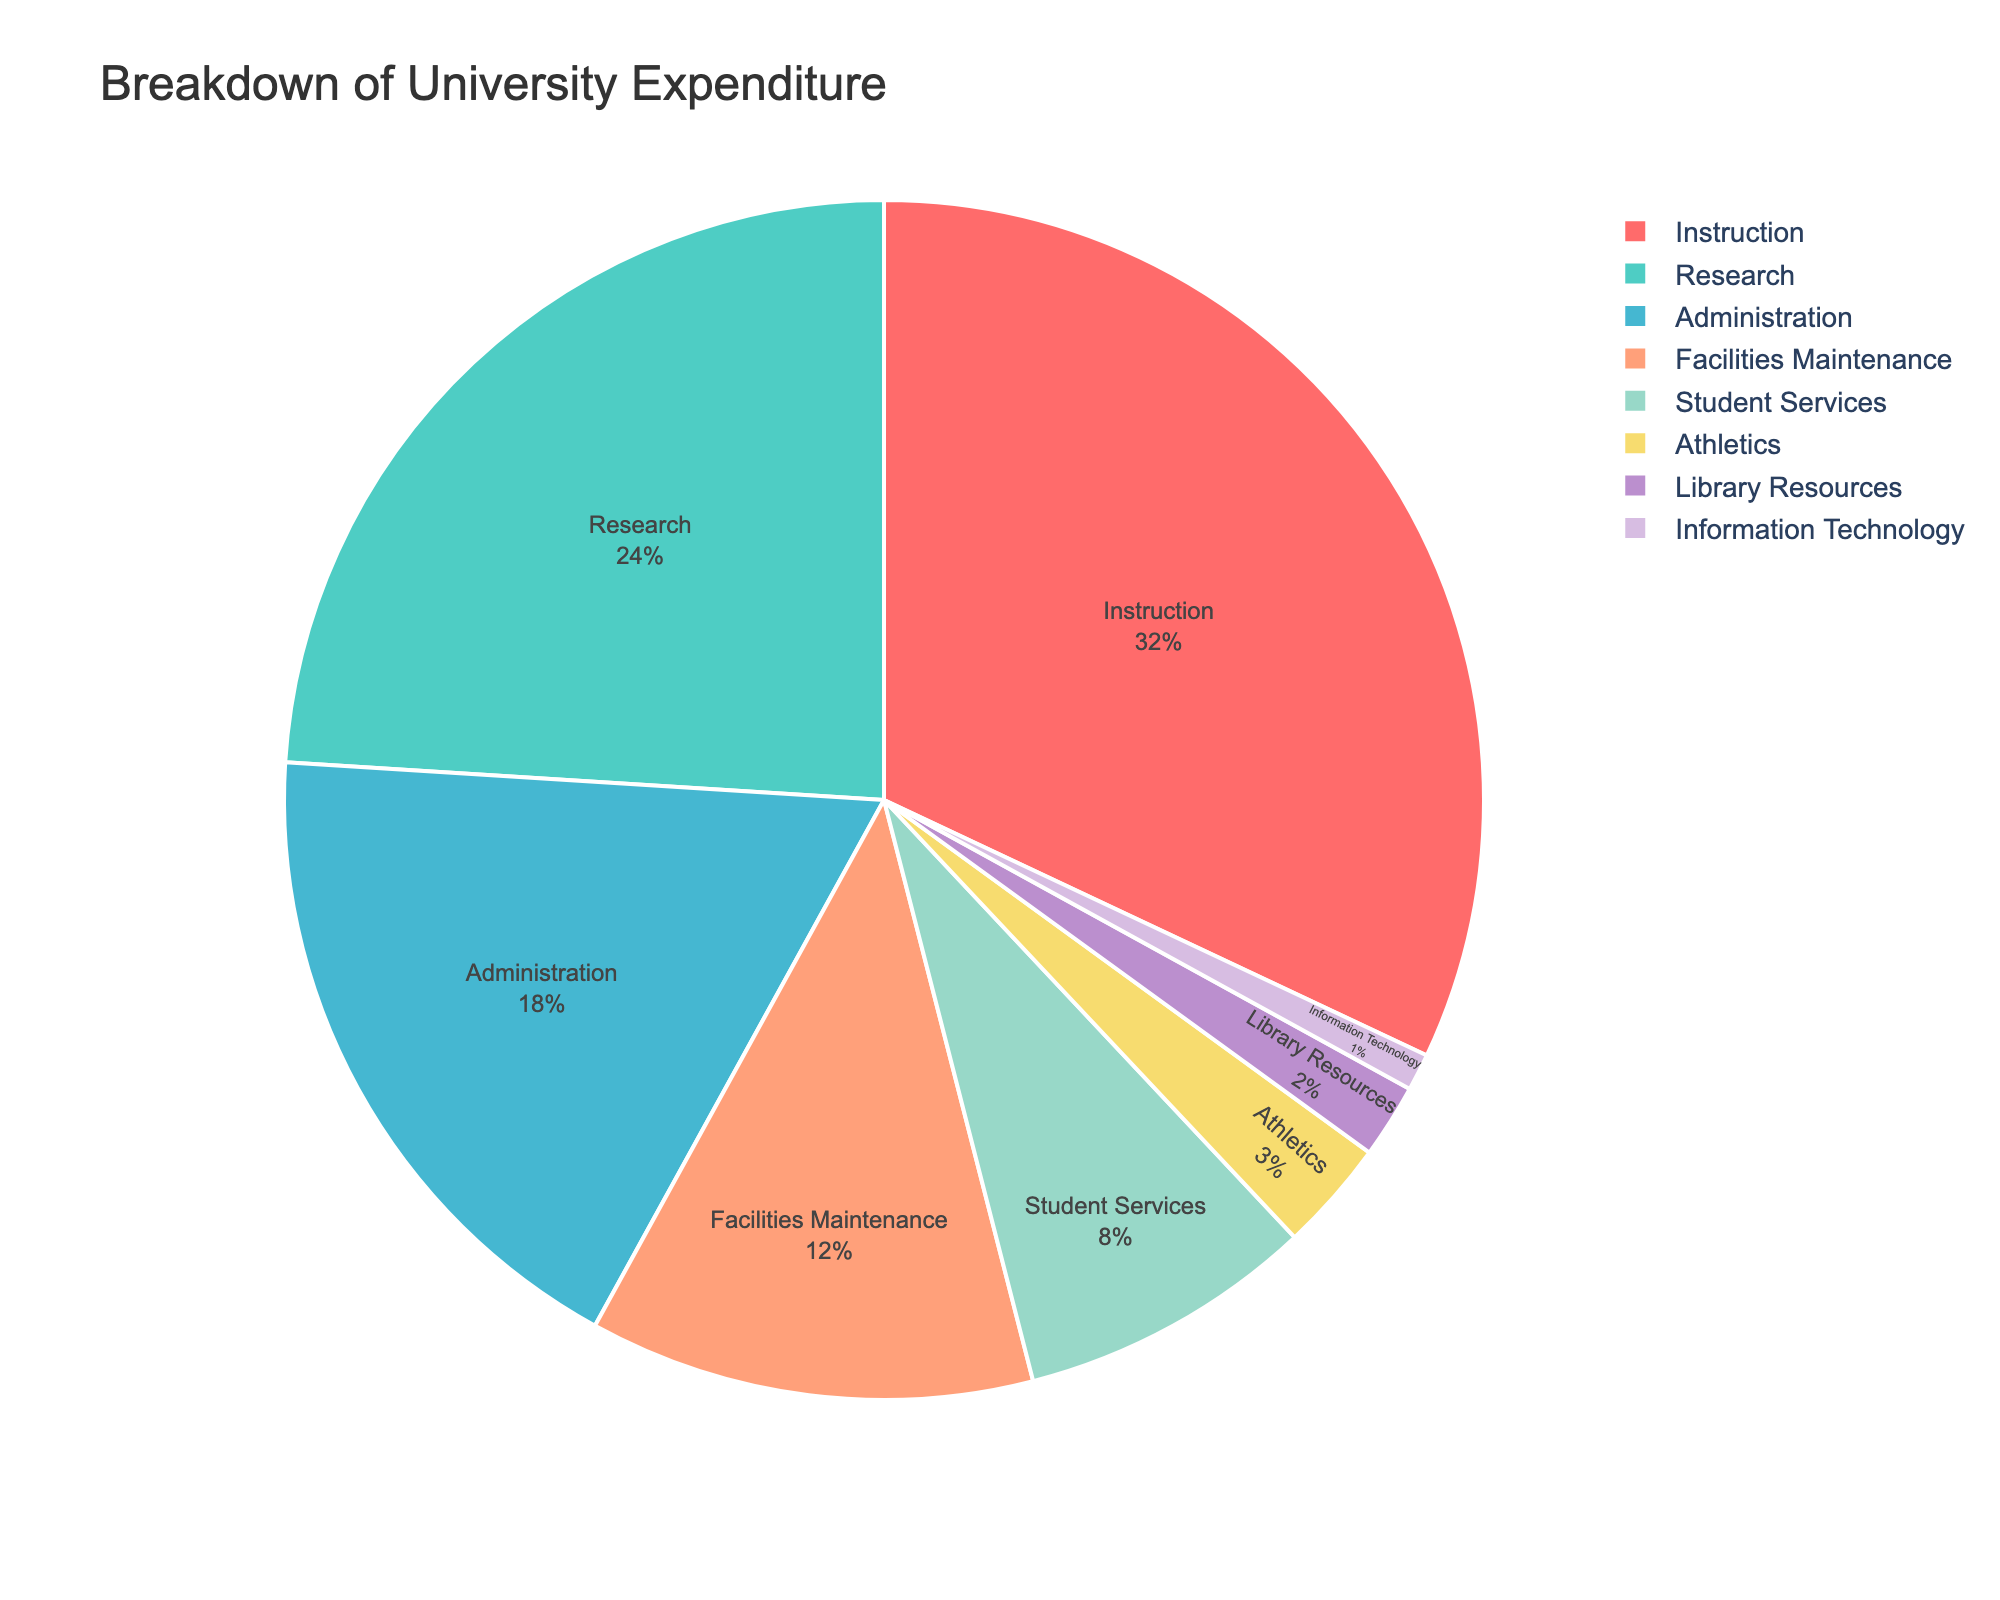What's the combined percentage of expenditure on Administration and Facilities Maintenance? To find the combined percentage, add the values associated with Administration and Facilities Maintenance: 18% (Administration) + 12% (Facilities Maintenance) = 30%.
Answer: 30% Which category has the highest expenditure? By looking at the pie chart and observing the segment sizes, Instruction has the largest segment corresponding to 32%.
Answer: Instruction How much greater is the expenditure on Research compared to Athletics? Subtract the percentage for Athletics from the percentage for Research: 24% (Research) - 3% (Athletics) = 21%.
Answer: 21% What percentage of expenditure is allocated to Student Services and Library Resources combined? To find the combined percentage, add the values for Student Services and Library Resources: 8% (Student Services) + 2% (Library Resources) = 10%.
Answer: 10% Is the expenditure on Information Technology less than 5%? By observing the pie chart segment for Information Technology, it is clear that the percentage is 1%, which is less than 5%.
Answer: Yes What is the total percentage of expenditure on non-instructional services (Research, Administration, Facilities Maintenance, Student Services, Athletics, Library Resources, Information Technology)? Sum the percentages for all non-instructional categories: 24% (Research) + 18% (Administration) + 12% (Facilities Maintenance) + 8% (Student Services) + 3% (Athletics) + 2% (Library Resources) + 1% (Information Technology) = 68%.
Answer: 68% Which category has the smallest slice in the pie chart? The category with the smallest slice is Information Technology, with a percentage of 1%.
Answer: Information Technology How many categories have an expenditure of less than 10%? Count the categories with percentages less than 10%: Student Services (8%), Athletics (3%), Library Resources (2%), Information Technology (1%). There are four such categories.
Answer: 4 Compare the expenditure on Instruction and Research. Which one is higher and by how much? Instruction has a percentage of 32%, and Research has 24%. Subtracting them: 32% - 24% = 8%. So, Instruction is higher by 8%.
Answer: Instruction by 8% 